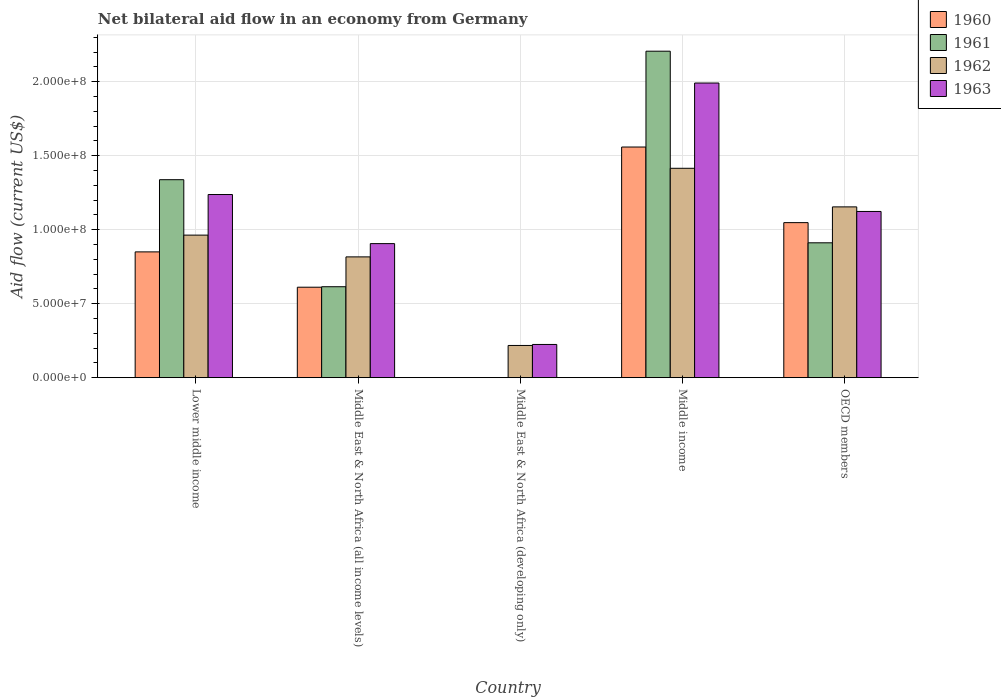How many different coloured bars are there?
Make the answer very short. 4. Are the number of bars on each tick of the X-axis equal?
Your response must be concise. No. What is the label of the 5th group of bars from the left?
Provide a short and direct response. OECD members. What is the net bilateral aid flow in 1960 in Middle East & North Africa (all income levels)?
Provide a succinct answer. 6.11e+07. Across all countries, what is the maximum net bilateral aid flow in 1960?
Offer a very short reply. 1.56e+08. Across all countries, what is the minimum net bilateral aid flow in 1962?
Provide a succinct answer. 2.18e+07. What is the total net bilateral aid flow in 1960 in the graph?
Make the answer very short. 4.07e+08. What is the difference between the net bilateral aid flow in 1963 in Lower middle income and that in Middle East & North Africa (all income levels)?
Provide a short and direct response. 3.32e+07. What is the difference between the net bilateral aid flow in 1963 in OECD members and the net bilateral aid flow in 1962 in Middle East & North Africa (developing only)?
Your answer should be compact. 9.06e+07. What is the average net bilateral aid flow in 1963 per country?
Offer a terse response. 1.10e+08. What is the difference between the net bilateral aid flow of/in 1962 and net bilateral aid flow of/in 1963 in Middle East & North Africa (all income levels)?
Give a very brief answer. -8.97e+06. In how many countries, is the net bilateral aid flow in 1963 greater than 70000000 US$?
Your response must be concise. 4. What is the ratio of the net bilateral aid flow in 1960 in Lower middle income to that in Middle income?
Keep it short and to the point. 0.55. Is the net bilateral aid flow in 1963 in Lower middle income less than that in OECD members?
Your answer should be very brief. No. What is the difference between the highest and the second highest net bilateral aid flow in 1961?
Keep it short and to the point. 8.69e+07. What is the difference between the highest and the lowest net bilateral aid flow in 1963?
Keep it short and to the point. 1.77e+08. Is the sum of the net bilateral aid flow in 1962 in Lower middle income and Middle East & North Africa (developing only) greater than the maximum net bilateral aid flow in 1961 across all countries?
Provide a succinct answer. No. Is it the case that in every country, the sum of the net bilateral aid flow in 1962 and net bilateral aid flow in 1963 is greater than the sum of net bilateral aid flow in 1960 and net bilateral aid flow in 1961?
Ensure brevity in your answer.  No. Is it the case that in every country, the sum of the net bilateral aid flow in 1960 and net bilateral aid flow in 1961 is greater than the net bilateral aid flow in 1963?
Your response must be concise. No. Are all the bars in the graph horizontal?
Your answer should be compact. No. How many countries are there in the graph?
Your answer should be compact. 5. Are the values on the major ticks of Y-axis written in scientific E-notation?
Your answer should be very brief. Yes. Does the graph contain grids?
Ensure brevity in your answer.  Yes. Where does the legend appear in the graph?
Give a very brief answer. Top right. How many legend labels are there?
Make the answer very short. 4. How are the legend labels stacked?
Your response must be concise. Vertical. What is the title of the graph?
Ensure brevity in your answer.  Net bilateral aid flow in an economy from Germany. What is the label or title of the X-axis?
Offer a very short reply. Country. What is the label or title of the Y-axis?
Give a very brief answer. Aid flow (current US$). What is the Aid flow (current US$) of 1960 in Lower middle income?
Provide a succinct answer. 8.50e+07. What is the Aid flow (current US$) of 1961 in Lower middle income?
Ensure brevity in your answer.  1.34e+08. What is the Aid flow (current US$) in 1962 in Lower middle income?
Provide a succinct answer. 9.64e+07. What is the Aid flow (current US$) of 1963 in Lower middle income?
Give a very brief answer. 1.24e+08. What is the Aid flow (current US$) of 1960 in Middle East & North Africa (all income levels)?
Your response must be concise. 6.11e+07. What is the Aid flow (current US$) of 1961 in Middle East & North Africa (all income levels)?
Offer a very short reply. 6.15e+07. What is the Aid flow (current US$) in 1962 in Middle East & North Africa (all income levels)?
Your response must be concise. 8.16e+07. What is the Aid flow (current US$) of 1963 in Middle East & North Africa (all income levels)?
Provide a succinct answer. 9.06e+07. What is the Aid flow (current US$) in 1960 in Middle East & North Africa (developing only)?
Offer a terse response. 0. What is the Aid flow (current US$) in 1961 in Middle East & North Africa (developing only)?
Make the answer very short. 0. What is the Aid flow (current US$) in 1962 in Middle East & North Africa (developing only)?
Give a very brief answer. 2.18e+07. What is the Aid flow (current US$) in 1963 in Middle East & North Africa (developing only)?
Provide a short and direct response. 2.24e+07. What is the Aid flow (current US$) of 1960 in Middle income?
Keep it short and to the point. 1.56e+08. What is the Aid flow (current US$) of 1961 in Middle income?
Provide a succinct answer. 2.21e+08. What is the Aid flow (current US$) in 1962 in Middle income?
Provide a succinct answer. 1.42e+08. What is the Aid flow (current US$) in 1963 in Middle income?
Offer a very short reply. 1.99e+08. What is the Aid flow (current US$) in 1960 in OECD members?
Ensure brevity in your answer.  1.05e+08. What is the Aid flow (current US$) in 1961 in OECD members?
Ensure brevity in your answer.  9.12e+07. What is the Aid flow (current US$) of 1962 in OECD members?
Give a very brief answer. 1.15e+08. What is the Aid flow (current US$) in 1963 in OECD members?
Ensure brevity in your answer.  1.12e+08. Across all countries, what is the maximum Aid flow (current US$) of 1960?
Offer a terse response. 1.56e+08. Across all countries, what is the maximum Aid flow (current US$) of 1961?
Give a very brief answer. 2.21e+08. Across all countries, what is the maximum Aid flow (current US$) of 1962?
Provide a succinct answer. 1.42e+08. Across all countries, what is the maximum Aid flow (current US$) of 1963?
Provide a short and direct response. 1.99e+08. Across all countries, what is the minimum Aid flow (current US$) in 1962?
Provide a succinct answer. 2.18e+07. Across all countries, what is the minimum Aid flow (current US$) of 1963?
Offer a terse response. 2.24e+07. What is the total Aid flow (current US$) of 1960 in the graph?
Make the answer very short. 4.07e+08. What is the total Aid flow (current US$) in 1961 in the graph?
Offer a terse response. 5.07e+08. What is the total Aid flow (current US$) of 1962 in the graph?
Your answer should be very brief. 4.57e+08. What is the total Aid flow (current US$) of 1963 in the graph?
Your answer should be compact. 5.48e+08. What is the difference between the Aid flow (current US$) in 1960 in Lower middle income and that in Middle East & North Africa (all income levels)?
Give a very brief answer. 2.39e+07. What is the difference between the Aid flow (current US$) in 1961 in Lower middle income and that in Middle East & North Africa (all income levels)?
Your response must be concise. 7.24e+07. What is the difference between the Aid flow (current US$) of 1962 in Lower middle income and that in Middle East & North Africa (all income levels)?
Ensure brevity in your answer.  1.47e+07. What is the difference between the Aid flow (current US$) in 1963 in Lower middle income and that in Middle East & North Africa (all income levels)?
Keep it short and to the point. 3.32e+07. What is the difference between the Aid flow (current US$) in 1962 in Lower middle income and that in Middle East & North Africa (developing only)?
Ensure brevity in your answer.  7.46e+07. What is the difference between the Aid flow (current US$) of 1963 in Lower middle income and that in Middle East & North Africa (developing only)?
Offer a very short reply. 1.01e+08. What is the difference between the Aid flow (current US$) in 1960 in Lower middle income and that in Middle income?
Keep it short and to the point. -7.09e+07. What is the difference between the Aid flow (current US$) in 1961 in Lower middle income and that in Middle income?
Keep it short and to the point. -8.69e+07. What is the difference between the Aid flow (current US$) in 1962 in Lower middle income and that in Middle income?
Your response must be concise. -4.52e+07. What is the difference between the Aid flow (current US$) of 1963 in Lower middle income and that in Middle income?
Your response must be concise. -7.54e+07. What is the difference between the Aid flow (current US$) in 1960 in Lower middle income and that in OECD members?
Offer a terse response. -1.98e+07. What is the difference between the Aid flow (current US$) in 1961 in Lower middle income and that in OECD members?
Provide a succinct answer. 4.27e+07. What is the difference between the Aid flow (current US$) of 1962 in Lower middle income and that in OECD members?
Give a very brief answer. -1.91e+07. What is the difference between the Aid flow (current US$) of 1963 in Lower middle income and that in OECD members?
Your answer should be very brief. 1.14e+07. What is the difference between the Aid flow (current US$) in 1962 in Middle East & North Africa (all income levels) and that in Middle East & North Africa (developing only)?
Keep it short and to the point. 5.99e+07. What is the difference between the Aid flow (current US$) of 1963 in Middle East & North Africa (all income levels) and that in Middle East & North Africa (developing only)?
Your response must be concise. 6.82e+07. What is the difference between the Aid flow (current US$) of 1960 in Middle East & North Africa (all income levels) and that in Middle income?
Your response must be concise. -9.48e+07. What is the difference between the Aid flow (current US$) of 1961 in Middle East & North Africa (all income levels) and that in Middle income?
Offer a terse response. -1.59e+08. What is the difference between the Aid flow (current US$) of 1962 in Middle East & North Africa (all income levels) and that in Middle income?
Your answer should be compact. -5.99e+07. What is the difference between the Aid flow (current US$) in 1963 in Middle East & North Africa (all income levels) and that in Middle income?
Keep it short and to the point. -1.09e+08. What is the difference between the Aid flow (current US$) in 1960 in Middle East & North Africa (all income levels) and that in OECD members?
Ensure brevity in your answer.  -4.37e+07. What is the difference between the Aid flow (current US$) in 1961 in Middle East & North Africa (all income levels) and that in OECD members?
Offer a very short reply. -2.97e+07. What is the difference between the Aid flow (current US$) of 1962 in Middle East & North Africa (all income levels) and that in OECD members?
Your answer should be very brief. -3.38e+07. What is the difference between the Aid flow (current US$) in 1963 in Middle East & North Africa (all income levels) and that in OECD members?
Provide a succinct answer. -2.17e+07. What is the difference between the Aid flow (current US$) of 1962 in Middle East & North Africa (developing only) and that in Middle income?
Provide a succinct answer. -1.20e+08. What is the difference between the Aid flow (current US$) in 1963 in Middle East & North Africa (developing only) and that in Middle income?
Provide a short and direct response. -1.77e+08. What is the difference between the Aid flow (current US$) of 1962 in Middle East & North Africa (developing only) and that in OECD members?
Your response must be concise. -9.37e+07. What is the difference between the Aid flow (current US$) of 1963 in Middle East & North Africa (developing only) and that in OECD members?
Keep it short and to the point. -8.99e+07. What is the difference between the Aid flow (current US$) of 1960 in Middle income and that in OECD members?
Your answer should be compact. 5.11e+07. What is the difference between the Aid flow (current US$) of 1961 in Middle income and that in OECD members?
Provide a succinct answer. 1.30e+08. What is the difference between the Aid flow (current US$) in 1962 in Middle income and that in OECD members?
Provide a succinct answer. 2.61e+07. What is the difference between the Aid flow (current US$) of 1963 in Middle income and that in OECD members?
Ensure brevity in your answer.  8.68e+07. What is the difference between the Aid flow (current US$) of 1960 in Lower middle income and the Aid flow (current US$) of 1961 in Middle East & North Africa (all income levels)?
Ensure brevity in your answer.  2.36e+07. What is the difference between the Aid flow (current US$) of 1960 in Lower middle income and the Aid flow (current US$) of 1962 in Middle East & North Africa (all income levels)?
Make the answer very short. 3.38e+06. What is the difference between the Aid flow (current US$) of 1960 in Lower middle income and the Aid flow (current US$) of 1963 in Middle East & North Africa (all income levels)?
Give a very brief answer. -5.59e+06. What is the difference between the Aid flow (current US$) in 1961 in Lower middle income and the Aid flow (current US$) in 1962 in Middle East & North Africa (all income levels)?
Make the answer very short. 5.22e+07. What is the difference between the Aid flow (current US$) in 1961 in Lower middle income and the Aid flow (current US$) in 1963 in Middle East & North Africa (all income levels)?
Your answer should be very brief. 4.32e+07. What is the difference between the Aid flow (current US$) in 1962 in Lower middle income and the Aid flow (current US$) in 1963 in Middle East & North Africa (all income levels)?
Offer a terse response. 5.75e+06. What is the difference between the Aid flow (current US$) of 1960 in Lower middle income and the Aid flow (current US$) of 1962 in Middle East & North Africa (developing only)?
Make the answer very short. 6.32e+07. What is the difference between the Aid flow (current US$) in 1960 in Lower middle income and the Aid flow (current US$) in 1963 in Middle East & North Africa (developing only)?
Your answer should be compact. 6.26e+07. What is the difference between the Aid flow (current US$) of 1961 in Lower middle income and the Aid flow (current US$) of 1962 in Middle East & North Africa (developing only)?
Provide a succinct answer. 1.12e+08. What is the difference between the Aid flow (current US$) of 1961 in Lower middle income and the Aid flow (current US$) of 1963 in Middle East & North Africa (developing only)?
Offer a very short reply. 1.11e+08. What is the difference between the Aid flow (current US$) of 1962 in Lower middle income and the Aid flow (current US$) of 1963 in Middle East & North Africa (developing only)?
Provide a succinct answer. 7.39e+07. What is the difference between the Aid flow (current US$) of 1960 in Lower middle income and the Aid flow (current US$) of 1961 in Middle income?
Your answer should be compact. -1.36e+08. What is the difference between the Aid flow (current US$) of 1960 in Lower middle income and the Aid flow (current US$) of 1962 in Middle income?
Give a very brief answer. -5.65e+07. What is the difference between the Aid flow (current US$) of 1960 in Lower middle income and the Aid flow (current US$) of 1963 in Middle income?
Your answer should be very brief. -1.14e+08. What is the difference between the Aid flow (current US$) of 1961 in Lower middle income and the Aid flow (current US$) of 1962 in Middle income?
Give a very brief answer. -7.71e+06. What is the difference between the Aid flow (current US$) of 1961 in Lower middle income and the Aid flow (current US$) of 1963 in Middle income?
Make the answer very short. -6.54e+07. What is the difference between the Aid flow (current US$) of 1962 in Lower middle income and the Aid flow (current US$) of 1963 in Middle income?
Offer a very short reply. -1.03e+08. What is the difference between the Aid flow (current US$) in 1960 in Lower middle income and the Aid flow (current US$) in 1961 in OECD members?
Your response must be concise. -6.14e+06. What is the difference between the Aid flow (current US$) in 1960 in Lower middle income and the Aid flow (current US$) in 1962 in OECD members?
Ensure brevity in your answer.  -3.04e+07. What is the difference between the Aid flow (current US$) in 1960 in Lower middle income and the Aid flow (current US$) in 1963 in OECD members?
Keep it short and to the point. -2.73e+07. What is the difference between the Aid flow (current US$) in 1961 in Lower middle income and the Aid flow (current US$) in 1962 in OECD members?
Your answer should be compact. 1.84e+07. What is the difference between the Aid flow (current US$) in 1961 in Lower middle income and the Aid flow (current US$) in 1963 in OECD members?
Ensure brevity in your answer.  2.15e+07. What is the difference between the Aid flow (current US$) of 1962 in Lower middle income and the Aid flow (current US$) of 1963 in OECD members?
Ensure brevity in your answer.  -1.60e+07. What is the difference between the Aid flow (current US$) in 1960 in Middle East & North Africa (all income levels) and the Aid flow (current US$) in 1962 in Middle East & North Africa (developing only)?
Your answer should be compact. 3.94e+07. What is the difference between the Aid flow (current US$) of 1960 in Middle East & North Africa (all income levels) and the Aid flow (current US$) of 1963 in Middle East & North Africa (developing only)?
Offer a very short reply. 3.87e+07. What is the difference between the Aid flow (current US$) in 1961 in Middle East & North Africa (all income levels) and the Aid flow (current US$) in 1962 in Middle East & North Africa (developing only)?
Your response must be concise. 3.97e+07. What is the difference between the Aid flow (current US$) of 1961 in Middle East & North Africa (all income levels) and the Aid flow (current US$) of 1963 in Middle East & North Africa (developing only)?
Your answer should be very brief. 3.90e+07. What is the difference between the Aid flow (current US$) of 1962 in Middle East & North Africa (all income levels) and the Aid flow (current US$) of 1963 in Middle East & North Africa (developing only)?
Give a very brief answer. 5.92e+07. What is the difference between the Aid flow (current US$) of 1960 in Middle East & North Africa (all income levels) and the Aid flow (current US$) of 1961 in Middle income?
Your answer should be compact. -1.60e+08. What is the difference between the Aid flow (current US$) in 1960 in Middle East & North Africa (all income levels) and the Aid flow (current US$) in 1962 in Middle income?
Make the answer very short. -8.04e+07. What is the difference between the Aid flow (current US$) in 1960 in Middle East & North Africa (all income levels) and the Aid flow (current US$) in 1963 in Middle income?
Ensure brevity in your answer.  -1.38e+08. What is the difference between the Aid flow (current US$) of 1961 in Middle East & North Africa (all income levels) and the Aid flow (current US$) of 1962 in Middle income?
Keep it short and to the point. -8.01e+07. What is the difference between the Aid flow (current US$) in 1961 in Middle East & North Africa (all income levels) and the Aid flow (current US$) in 1963 in Middle income?
Offer a terse response. -1.38e+08. What is the difference between the Aid flow (current US$) in 1962 in Middle East & North Africa (all income levels) and the Aid flow (current US$) in 1963 in Middle income?
Your answer should be very brief. -1.18e+08. What is the difference between the Aid flow (current US$) in 1960 in Middle East & North Africa (all income levels) and the Aid flow (current US$) in 1961 in OECD members?
Provide a succinct answer. -3.00e+07. What is the difference between the Aid flow (current US$) in 1960 in Middle East & North Africa (all income levels) and the Aid flow (current US$) in 1962 in OECD members?
Give a very brief answer. -5.43e+07. What is the difference between the Aid flow (current US$) of 1960 in Middle East & North Africa (all income levels) and the Aid flow (current US$) of 1963 in OECD members?
Give a very brief answer. -5.12e+07. What is the difference between the Aid flow (current US$) of 1961 in Middle East & North Africa (all income levels) and the Aid flow (current US$) of 1962 in OECD members?
Your answer should be very brief. -5.40e+07. What is the difference between the Aid flow (current US$) in 1961 in Middle East & North Africa (all income levels) and the Aid flow (current US$) in 1963 in OECD members?
Give a very brief answer. -5.09e+07. What is the difference between the Aid flow (current US$) of 1962 in Middle East & North Africa (all income levels) and the Aid flow (current US$) of 1963 in OECD members?
Your answer should be compact. -3.07e+07. What is the difference between the Aid flow (current US$) in 1962 in Middle East & North Africa (developing only) and the Aid flow (current US$) in 1963 in Middle income?
Provide a succinct answer. -1.77e+08. What is the difference between the Aid flow (current US$) in 1962 in Middle East & North Africa (developing only) and the Aid flow (current US$) in 1963 in OECD members?
Make the answer very short. -9.06e+07. What is the difference between the Aid flow (current US$) in 1960 in Middle income and the Aid flow (current US$) in 1961 in OECD members?
Keep it short and to the point. 6.48e+07. What is the difference between the Aid flow (current US$) in 1960 in Middle income and the Aid flow (current US$) in 1962 in OECD members?
Ensure brevity in your answer.  4.05e+07. What is the difference between the Aid flow (current US$) in 1960 in Middle income and the Aid flow (current US$) in 1963 in OECD members?
Provide a succinct answer. 4.36e+07. What is the difference between the Aid flow (current US$) of 1961 in Middle income and the Aid flow (current US$) of 1962 in OECD members?
Provide a short and direct response. 1.05e+08. What is the difference between the Aid flow (current US$) of 1961 in Middle income and the Aid flow (current US$) of 1963 in OECD members?
Ensure brevity in your answer.  1.08e+08. What is the difference between the Aid flow (current US$) in 1962 in Middle income and the Aid flow (current US$) in 1963 in OECD members?
Your answer should be very brief. 2.92e+07. What is the average Aid flow (current US$) in 1960 per country?
Your answer should be compact. 8.14e+07. What is the average Aid flow (current US$) of 1961 per country?
Offer a very short reply. 1.01e+08. What is the average Aid flow (current US$) of 1962 per country?
Your answer should be very brief. 9.13e+07. What is the average Aid flow (current US$) in 1963 per country?
Your answer should be compact. 1.10e+08. What is the difference between the Aid flow (current US$) in 1960 and Aid flow (current US$) in 1961 in Lower middle income?
Provide a short and direct response. -4.88e+07. What is the difference between the Aid flow (current US$) in 1960 and Aid flow (current US$) in 1962 in Lower middle income?
Ensure brevity in your answer.  -1.13e+07. What is the difference between the Aid flow (current US$) of 1960 and Aid flow (current US$) of 1963 in Lower middle income?
Offer a very short reply. -3.88e+07. What is the difference between the Aid flow (current US$) of 1961 and Aid flow (current US$) of 1962 in Lower middle income?
Make the answer very short. 3.75e+07. What is the difference between the Aid flow (current US$) in 1961 and Aid flow (current US$) in 1963 in Lower middle income?
Ensure brevity in your answer.  1.00e+07. What is the difference between the Aid flow (current US$) in 1962 and Aid flow (current US$) in 1963 in Lower middle income?
Your response must be concise. -2.74e+07. What is the difference between the Aid flow (current US$) of 1960 and Aid flow (current US$) of 1961 in Middle East & North Africa (all income levels)?
Your answer should be very brief. -3.30e+05. What is the difference between the Aid flow (current US$) in 1960 and Aid flow (current US$) in 1962 in Middle East & North Africa (all income levels)?
Provide a succinct answer. -2.05e+07. What is the difference between the Aid flow (current US$) in 1960 and Aid flow (current US$) in 1963 in Middle East & North Africa (all income levels)?
Your answer should be compact. -2.95e+07. What is the difference between the Aid flow (current US$) of 1961 and Aid flow (current US$) of 1962 in Middle East & North Africa (all income levels)?
Keep it short and to the point. -2.02e+07. What is the difference between the Aid flow (current US$) of 1961 and Aid flow (current US$) of 1963 in Middle East & North Africa (all income levels)?
Ensure brevity in your answer.  -2.91e+07. What is the difference between the Aid flow (current US$) of 1962 and Aid flow (current US$) of 1963 in Middle East & North Africa (all income levels)?
Make the answer very short. -8.97e+06. What is the difference between the Aid flow (current US$) in 1962 and Aid flow (current US$) in 1963 in Middle East & North Africa (developing only)?
Your response must be concise. -6.70e+05. What is the difference between the Aid flow (current US$) in 1960 and Aid flow (current US$) in 1961 in Middle income?
Your answer should be compact. -6.48e+07. What is the difference between the Aid flow (current US$) in 1960 and Aid flow (current US$) in 1962 in Middle income?
Make the answer very short. 1.44e+07. What is the difference between the Aid flow (current US$) in 1960 and Aid flow (current US$) in 1963 in Middle income?
Offer a terse response. -4.33e+07. What is the difference between the Aid flow (current US$) in 1961 and Aid flow (current US$) in 1962 in Middle income?
Ensure brevity in your answer.  7.92e+07. What is the difference between the Aid flow (current US$) of 1961 and Aid flow (current US$) of 1963 in Middle income?
Make the answer very short. 2.15e+07. What is the difference between the Aid flow (current US$) in 1962 and Aid flow (current US$) in 1963 in Middle income?
Keep it short and to the point. -5.76e+07. What is the difference between the Aid flow (current US$) in 1960 and Aid flow (current US$) in 1961 in OECD members?
Ensure brevity in your answer.  1.36e+07. What is the difference between the Aid flow (current US$) of 1960 and Aid flow (current US$) of 1962 in OECD members?
Provide a short and direct response. -1.06e+07. What is the difference between the Aid flow (current US$) in 1960 and Aid flow (current US$) in 1963 in OECD members?
Ensure brevity in your answer.  -7.55e+06. What is the difference between the Aid flow (current US$) of 1961 and Aid flow (current US$) of 1962 in OECD members?
Make the answer very short. -2.43e+07. What is the difference between the Aid flow (current US$) of 1961 and Aid flow (current US$) of 1963 in OECD members?
Your answer should be compact. -2.12e+07. What is the difference between the Aid flow (current US$) of 1962 and Aid flow (current US$) of 1963 in OECD members?
Give a very brief answer. 3.09e+06. What is the ratio of the Aid flow (current US$) of 1960 in Lower middle income to that in Middle East & North Africa (all income levels)?
Ensure brevity in your answer.  1.39. What is the ratio of the Aid flow (current US$) of 1961 in Lower middle income to that in Middle East & North Africa (all income levels)?
Offer a very short reply. 2.18. What is the ratio of the Aid flow (current US$) in 1962 in Lower middle income to that in Middle East & North Africa (all income levels)?
Your answer should be very brief. 1.18. What is the ratio of the Aid flow (current US$) in 1963 in Lower middle income to that in Middle East & North Africa (all income levels)?
Provide a short and direct response. 1.37. What is the ratio of the Aid flow (current US$) of 1962 in Lower middle income to that in Middle East & North Africa (developing only)?
Your answer should be very brief. 4.43. What is the ratio of the Aid flow (current US$) of 1963 in Lower middle income to that in Middle East & North Africa (developing only)?
Your answer should be compact. 5.52. What is the ratio of the Aid flow (current US$) in 1960 in Lower middle income to that in Middle income?
Make the answer very short. 0.55. What is the ratio of the Aid flow (current US$) in 1961 in Lower middle income to that in Middle income?
Your response must be concise. 0.61. What is the ratio of the Aid flow (current US$) of 1962 in Lower middle income to that in Middle income?
Give a very brief answer. 0.68. What is the ratio of the Aid flow (current US$) of 1963 in Lower middle income to that in Middle income?
Provide a succinct answer. 0.62. What is the ratio of the Aid flow (current US$) of 1960 in Lower middle income to that in OECD members?
Provide a short and direct response. 0.81. What is the ratio of the Aid flow (current US$) in 1961 in Lower middle income to that in OECD members?
Provide a short and direct response. 1.47. What is the ratio of the Aid flow (current US$) of 1962 in Lower middle income to that in OECD members?
Keep it short and to the point. 0.83. What is the ratio of the Aid flow (current US$) in 1963 in Lower middle income to that in OECD members?
Keep it short and to the point. 1.1. What is the ratio of the Aid flow (current US$) in 1962 in Middle East & North Africa (all income levels) to that in Middle East & North Africa (developing only)?
Offer a very short reply. 3.75. What is the ratio of the Aid flow (current US$) of 1963 in Middle East & North Africa (all income levels) to that in Middle East & North Africa (developing only)?
Your answer should be very brief. 4.04. What is the ratio of the Aid flow (current US$) in 1960 in Middle East & North Africa (all income levels) to that in Middle income?
Provide a succinct answer. 0.39. What is the ratio of the Aid flow (current US$) of 1961 in Middle East & North Africa (all income levels) to that in Middle income?
Provide a short and direct response. 0.28. What is the ratio of the Aid flow (current US$) in 1962 in Middle East & North Africa (all income levels) to that in Middle income?
Ensure brevity in your answer.  0.58. What is the ratio of the Aid flow (current US$) of 1963 in Middle East & North Africa (all income levels) to that in Middle income?
Your answer should be compact. 0.45. What is the ratio of the Aid flow (current US$) of 1960 in Middle East & North Africa (all income levels) to that in OECD members?
Offer a very short reply. 0.58. What is the ratio of the Aid flow (current US$) in 1961 in Middle East & North Africa (all income levels) to that in OECD members?
Provide a succinct answer. 0.67. What is the ratio of the Aid flow (current US$) in 1962 in Middle East & North Africa (all income levels) to that in OECD members?
Ensure brevity in your answer.  0.71. What is the ratio of the Aid flow (current US$) of 1963 in Middle East & North Africa (all income levels) to that in OECD members?
Your answer should be compact. 0.81. What is the ratio of the Aid flow (current US$) of 1962 in Middle East & North Africa (developing only) to that in Middle income?
Ensure brevity in your answer.  0.15. What is the ratio of the Aid flow (current US$) of 1963 in Middle East & North Africa (developing only) to that in Middle income?
Your answer should be very brief. 0.11. What is the ratio of the Aid flow (current US$) of 1962 in Middle East & North Africa (developing only) to that in OECD members?
Give a very brief answer. 0.19. What is the ratio of the Aid flow (current US$) in 1963 in Middle East & North Africa (developing only) to that in OECD members?
Provide a succinct answer. 0.2. What is the ratio of the Aid flow (current US$) of 1960 in Middle income to that in OECD members?
Ensure brevity in your answer.  1.49. What is the ratio of the Aid flow (current US$) in 1961 in Middle income to that in OECD members?
Keep it short and to the point. 2.42. What is the ratio of the Aid flow (current US$) of 1962 in Middle income to that in OECD members?
Provide a short and direct response. 1.23. What is the ratio of the Aid flow (current US$) of 1963 in Middle income to that in OECD members?
Offer a very short reply. 1.77. What is the difference between the highest and the second highest Aid flow (current US$) of 1960?
Your answer should be compact. 5.11e+07. What is the difference between the highest and the second highest Aid flow (current US$) in 1961?
Your answer should be compact. 8.69e+07. What is the difference between the highest and the second highest Aid flow (current US$) in 1962?
Your answer should be very brief. 2.61e+07. What is the difference between the highest and the second highest Aid flow (current US$) of 1963?
Your answer should be very brief. 7.54e+07. What is the difference between the highest and the lowest Aid flow (current US$) of 1960?
Provide a succinct answer. 1.56e+08. What is the difference between the highest and the lowest Aid flow (current US$) in 1961?
Your response must be concise. 2.21e+08. What is the difference between the highest and the lowest Aid flow (current US$) of 1962?
Keep it short and to the point. 1.20e+08. What is the difference between the highest and the lowest Aid flow (current US$) of 1963?
Keep it short and to the point. 1.77e+08. 